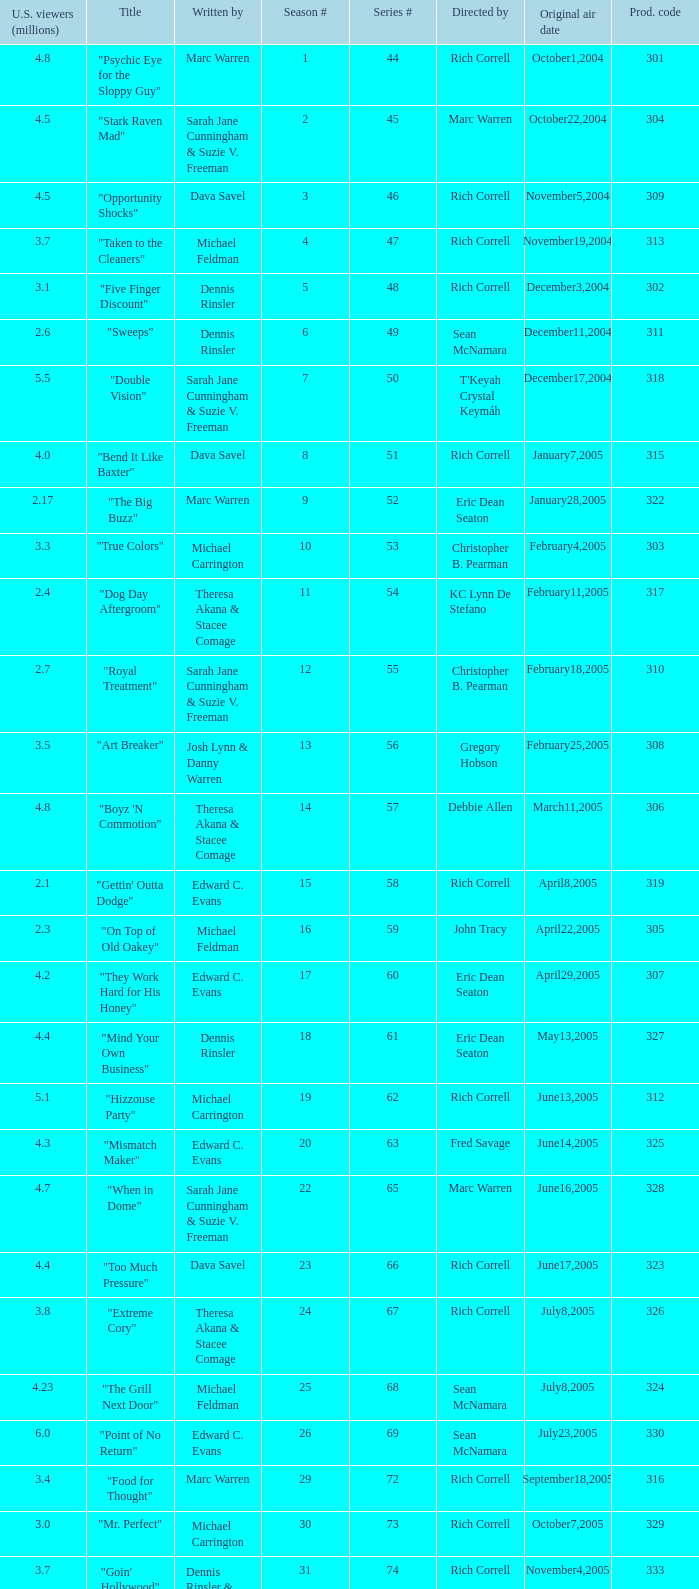What was the production code of the episode directed by Rondell Sheridan?  332.0. 